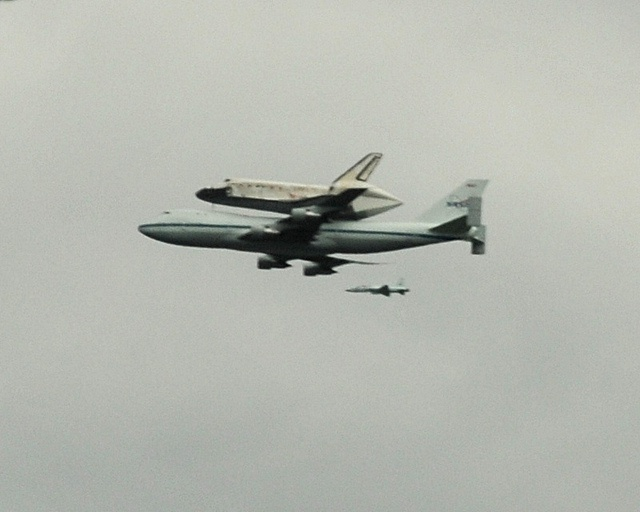Describe the objects in this image and their specific colors. I can see airplane in gray, black, darkgray, and lightgray tones and airplane in gray, darkgray, black, and lightgray tones in this image. 